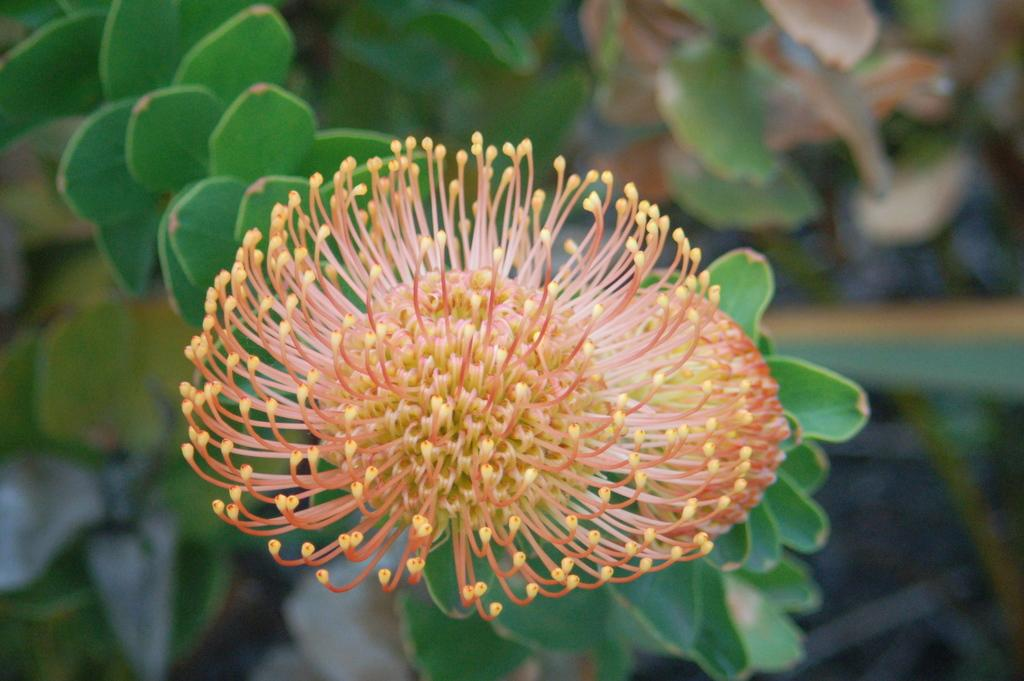What is the main subject of the image? There is a flower in the image. Can you describe the colors of the flower? The flower has orange and yellow colors. What else can be seen in the image besides the flower? There are leaves in the image. What color are the leaves? The leaves have a green color. How would you describe the background of the image? The background of the image is blurred. What type of punishment is being administered to the flower in the image? There is no punishment being administered to the flower in the image; it is simply a flower with leaves and a blurred background. 